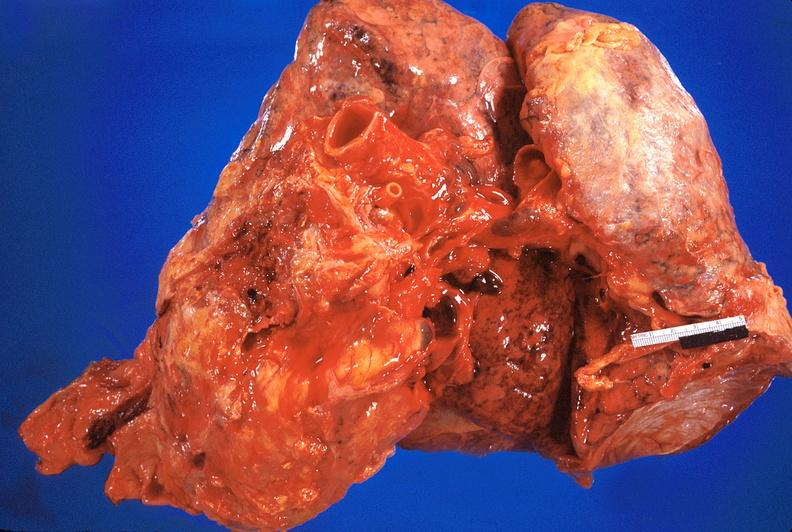s cardiovascular present?
Answer the question using a single word or phrase. Yes 